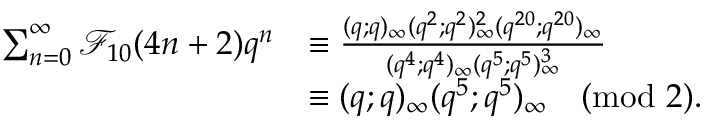<formula> <loc_0><loc_0><loc_500><loc_500>\begin{array} { r l } { \sum _ { n = 0 } ^ { \infty } \mathcal { F } _ { 1 0 } ( 4 n + 2 ) q ^ { n } } & { \equiv \frac { ( q ; q ) _ { \infty } ( q ^ { 2 } ; q ^ { 2 } ) _ { \infty } ^ { 2 } ( q ^ { 2 0 } ; q ^ { 2 0 } ) _ { \infty } } { ( q ^ { 4 } ; q ^ { 4 } ) _ { \infty } ( q ^ { 5 } ; q ^ { 5 } ) _ { \infty } ^ { 3 } } } \\ & { \equiv ( q ; q ) _ { \infty } ( q ^ { 5 } ; q ^ { 5 } ) _ { \infty } \pmod { 2 } . } \end{array}</formula> 